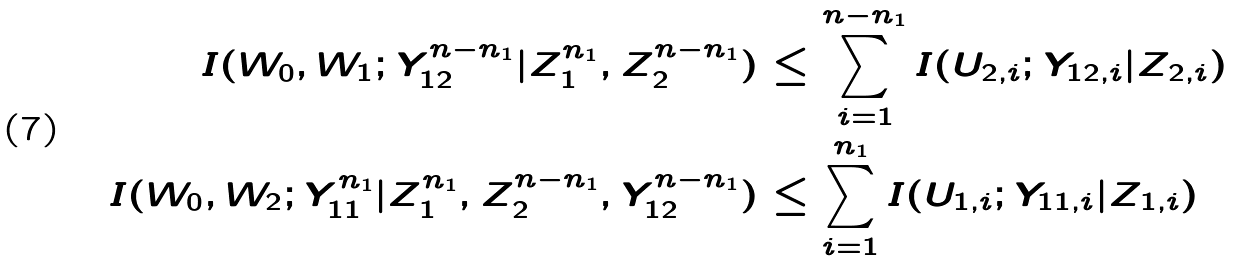<formula> <loc_0><loc_0><loc_500><loc_500>I ( W _ { 0 } , W _ { 1 } ; Y _ { 1 2 } ^ { n - n _ { 1 } } | Z _ { 1 } ^ { n _ { 1 } } , Z _ { 2 } ^ { n - n _ { 1 } } ) & \leq \sum _ { i = 1 } ^ { n - n _ { 1 } } I ( U _ { 2 , i } ; Y _ { 1 2 , i } | Z _ { 2 , i } ) \\ I ( W _ { 0 } , W _ { 2 } ; Y _ { 1 1 } ^ { n _ { 1 } } | Z _ { 1 } ^ { n _ { 1 } } , Z _ { 2 } ^ { n - n _ { 1 } } , Y _ { 1 2 } ^ { n - n _ { 1 } } ) & \leq \sum _ { i = 1 } ^ { n _ { 1 } } I ( U _ { 1 , i } ; Y _ { 1 1 , i } | Z _ { 1 , i } )</formula> 